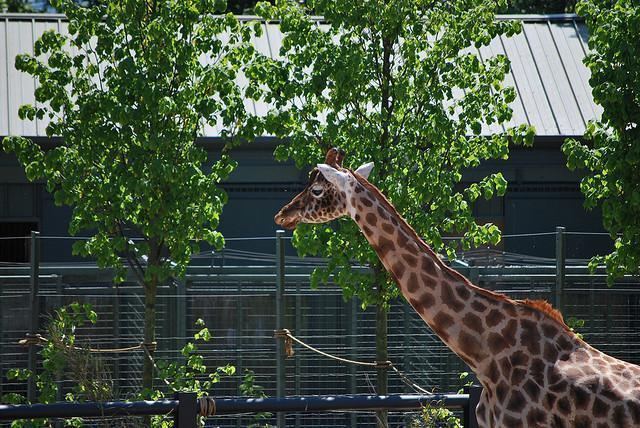How many elephants are in the picture?
Give a very brief answer. 0. 